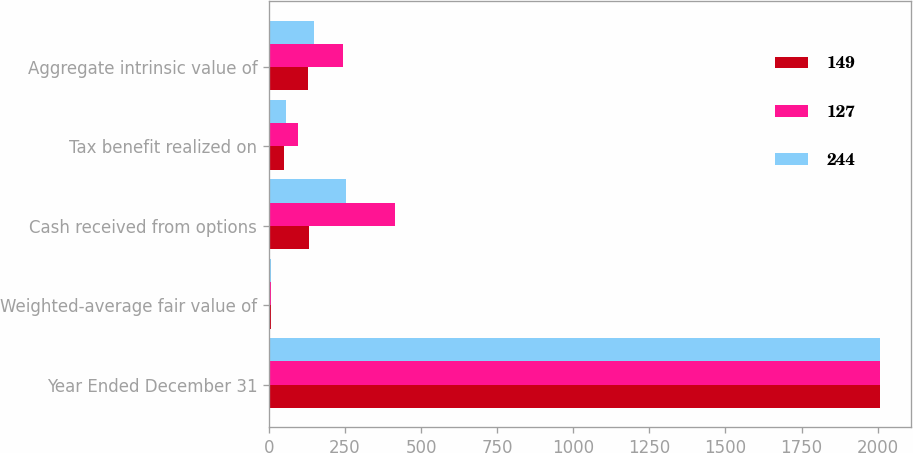<chart> <loc_0><loc_0><loc_500><loc_500><stacked_bar_chart><ecel><fcel>Year Ended December 31<fcel>Weighted-average fair value of<fcel>Cash received from options<fcel>Tax benefit realized on<fcel>Aggregate intrinsic value of<nl><fcel>149<fcel>2008<fcel>7.94<fcel>131<fcel>48<fcel>127<nl><fcel>127<fcel>2007<fcel>7.06<fcel>414<fcel>97<fcel>244<nl><fcel>244<fcel>2006<fcel>5.43<fcel>252<fcel>57<fcel>149<nl></chart> 